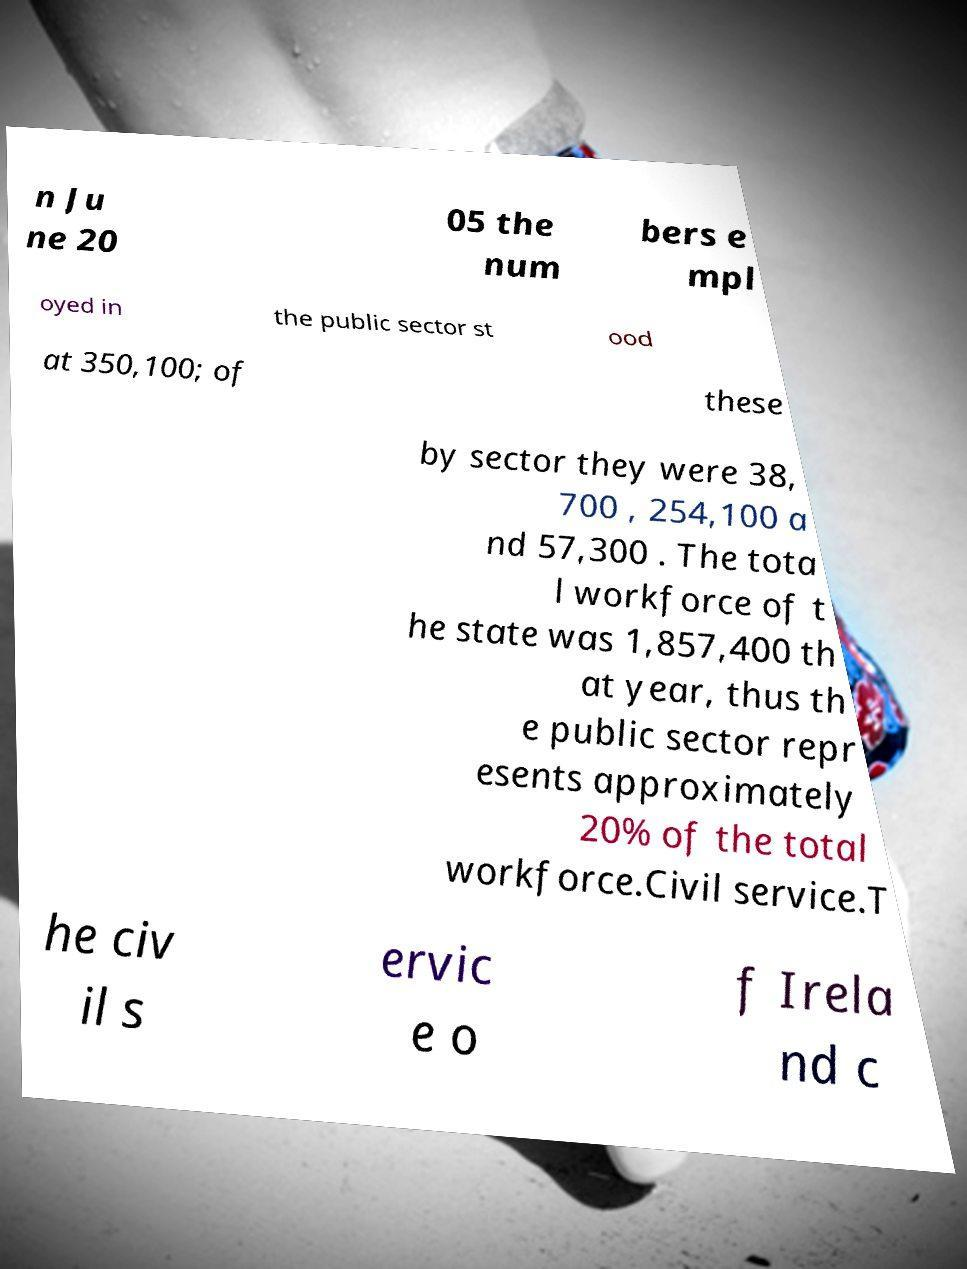What messages or text are displayed in this image? I need them in a readable, typed format. n Ju ne 20 05 the num bers e mpl oyed in the public sector st ood at 350,100; of these by sector they were 38, 700 , 254,100 a nd 57,300 . The tota l workforce of t he state was 1,857,400 th at year, thus th e public sector repr esents approximately 20% of the total workforce.Civil service.T he civ il s ervic e o f Irela nd c 